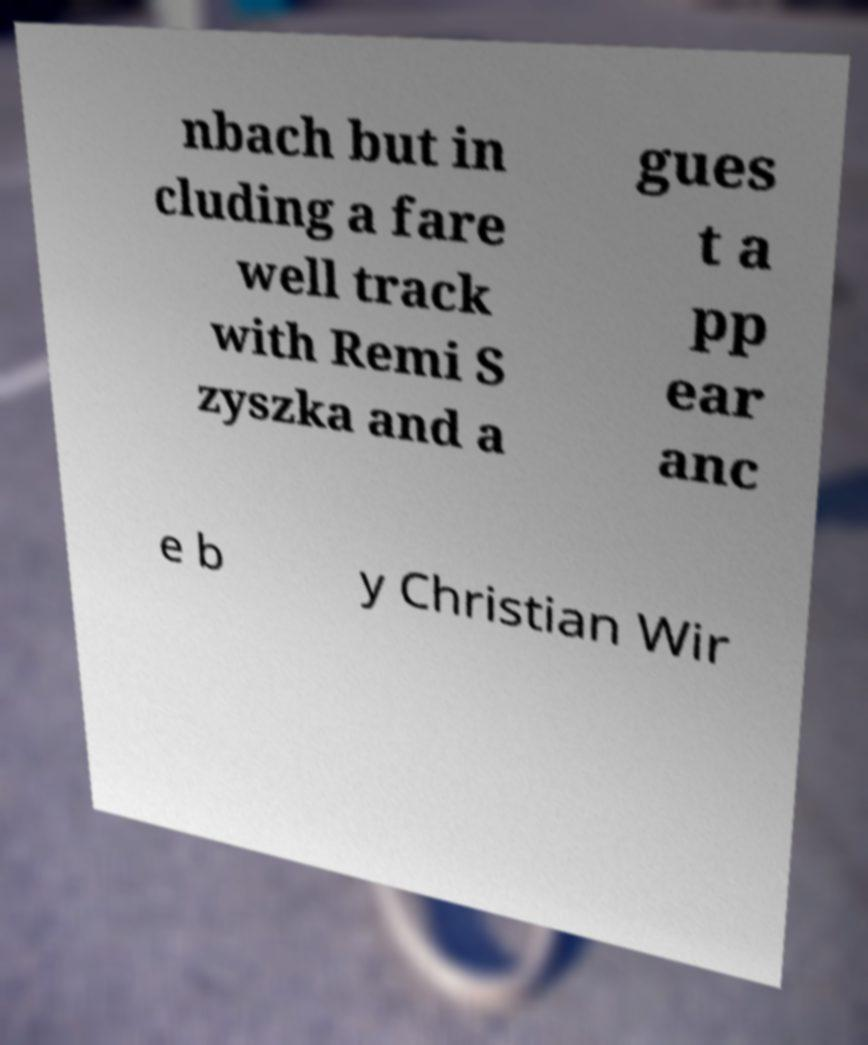Could you extract and type out the text from this image? nbach but in cluding a fare well track with Remi S zyszka and a gues t a pp ear anc e b y Christian Wir 